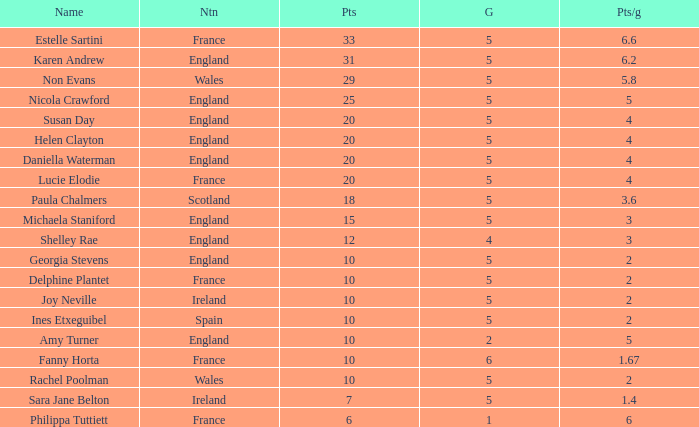Can you tell me the average Points that has a Pts/game larger than 4, and the Nation of england, and the Games smaller than 5? 10.0. 